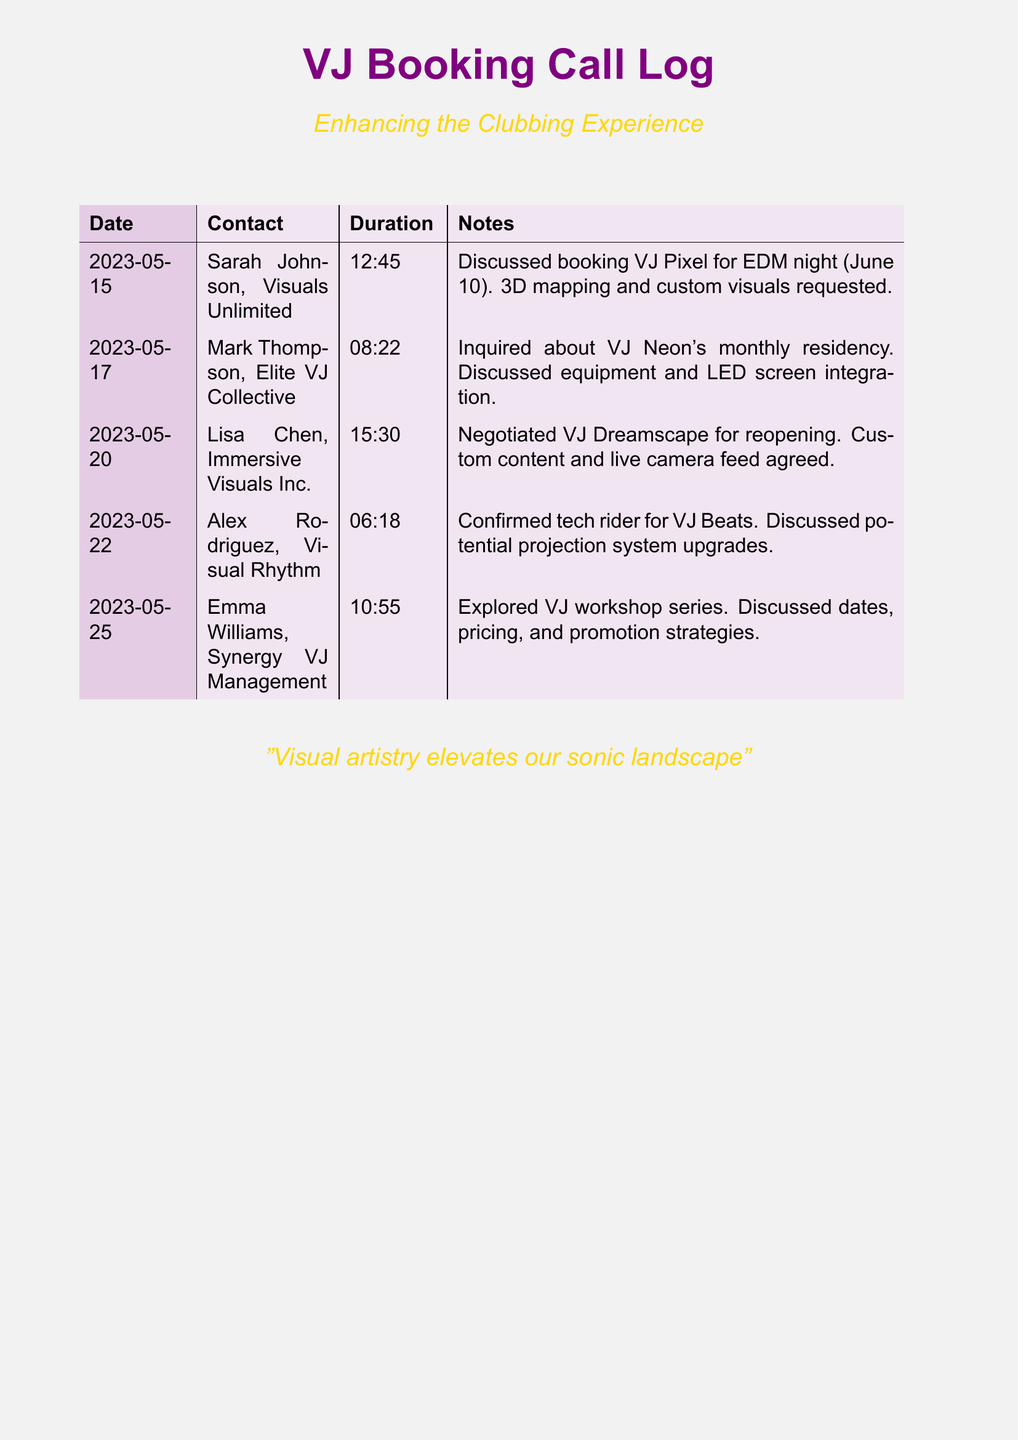What is the date of the discussion with Sarah Johnson? The date is listed in the logs, specifically showing when Sarah Johnson was contacted regarding the VJ booking.
Answer: 2023-05-15 Who is the contact for the VJ workshop series? The contact name for the VJ workshop series is provided in the log entries specifically where this topic is discussed.
Answer: Emma Williams What was discussed during the May 17 call? The notes section highlights the key points discussed during the May 17 call, specifically naming the VJ and related topics.
Answer: VJ Neon's monthly residency Which VJ was confirmed with tech rider on May 22? The log details specifically mentions the VJ that was confirmed for the tech rider during that date.
Answer: VJ Beats How long was the call with Lisa Chen? The duration of the call is indicated clearly in the log for that particular discussion.
Answer: 15:30 What is the primary requirement for VJ Pixel on June 10? The specific request regarding VJ Pixel during the call is clearly stated in the notes section of that entry.
Answer: 3D mapping and custom visuals Did any bookings involve custom content? The logs provide information about specific discussions that mention custom content during bookings or negotiations.
Answer: Yes What was the duration of the call with Mark Thompson? The duration is provided in the log for the call with Mark Thompson discussing the VJ residency.
Answer: 08:22 